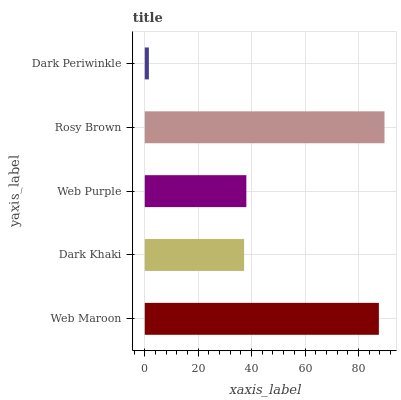Is Dark Periwinkle the minimum?
Answer yes or no. Yes. Is Rosy Brown the maximum?
Answer yes or no. Yes. Is Dark Khaki the minimum?
Answer yes or no. No. Is Dark Khaki the maximum?
Answer yes or no. No. Is Web Maroon greater than Dark Khaki?
Answer yes or no. Yes. Is Dark Khaki less than Web Maroon?
Answer yes or no. Yes. Is Dark Khaki greater than Web Maroon?
Answer yes or no. No. Is Web Maroon less than Dark Khaki?
Answer yes or no. No. Is Web Purple the high median?
Answer yes or no. Yes. Is Web Purple the low median?
Answer yes or no. Yes. Is Web Maroon the high median?
Answer yes or no. No. Is Dark Periwinkle the low median?
Answer yes or no. No. 